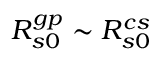<formula> <loc_0><loc_0><loc_500><loc_500>R _ { s 0 } ^ { g p } \sim R _ { s 0 } ^ { c s }</formula> 